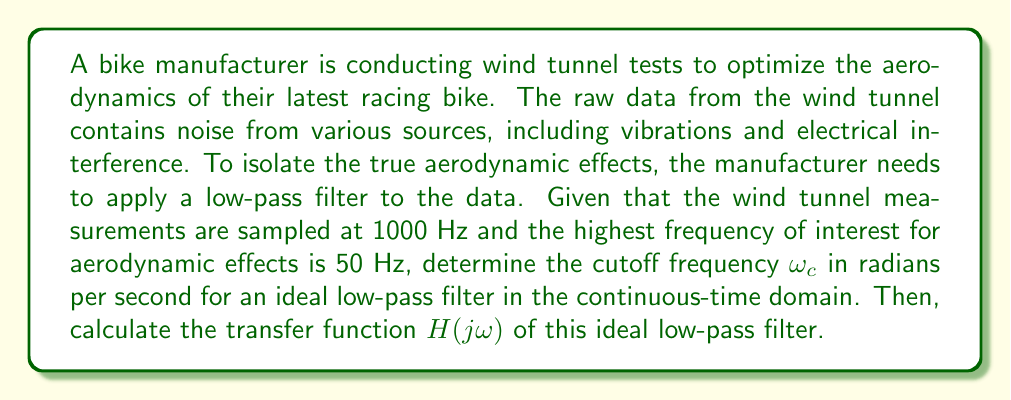Help me with this question. To solve this problem, we'll follow these steps:

1) First, we need to determine the cutoff frequency in Hz. Since the highest frequency of interest is 50 Hz, we'll set our cutoff frequency to this value:

   $f_c = 50$ Hz

2) To convert this to radians per second, we use the formula:

   $\omega_c = 2\pi f_c$

   $\omega_c = 2\pi(50) = 100\pi$ rad/s

3) Now that we have the cutoff frequency, we can define the transfer function of an ideal low-pass filter. The transfer function of an ideal low-pass filter in the continuous-time domain is:

   $$H(j\omega) = \begin{cases} 
   1, & |\omega| \leq \omega_c \\
   0, & |\omega| > \omega_c
   \end{cases}$$

4) Substituting our calculated $\omega_c$, we get:

   $$H(j\omega) = \begin{cases} 
   1, & |\omega| \leq 100\pi \\
   0, & |\omega| > 100\pi
   \end{cases}$$

This transfer function will pass all frequencies below 50 Hz (or 100π rad/s) without attenuation, and completely block all higher frequencies, effectively filtering out high-frequency noise and isolating the aerodynamic effects of interest.
Answer: The cutoff frequency is $\omega_c = 100\pi$ rad/s, and the transfer function of the ideal low-pass filter is:

$$H(j\omega) = \begin{cases} 
1, & |\omega| \leq 100\pi \\
0, & |\omega| > 100\pi
\end{cases}$$ 